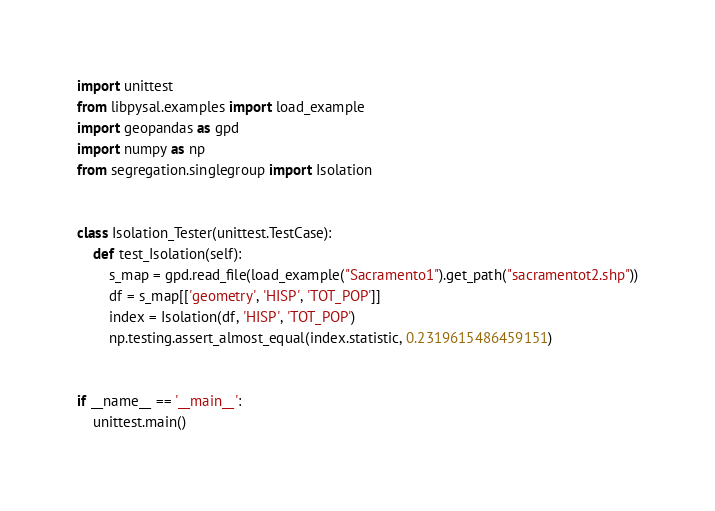<code> <loc_0><loc_0><loc_500><loc_500><_Python_>import unittest
from libpysal.examples import load_example
import geopandas as gpd
import numpy as np
from segregation.singlegroup import Isolation


class Isolation_Tester(unittest.TestCase):
    def test_Isolation(self):
        s_map = gpd.read_file(load_example("Sacramento1").get_path("sacramentot2.shp"))
        df = s_map[['geometry', 'HISP', 'TOT_POP']]
        index = Isolation(df, 'HISP', 'TOT_POP')
        np.testing.assert_almost_equal(index.statistic, 0.2319615486459151)


if __name__ == '__main__':
    unittest.main()
</code> 